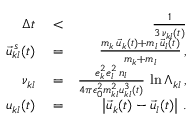Convert formula to latex. <formula><loc_0><loc_0><loc_500><loc_500>\begin{array} { r l r } { \Delta t } & < } & { \frac { 1 } { 3 \, \nu _ { k l } ( t ) } } \\ { \vec { u } _ { k l } ^ { \, s } ( t ) } & = } & { \frac { m _ { k } \, \vec { u } _ { k } ( t ) + m _ { l } \, \vec { u } _ { l } ( t ) } { m _ { k } + m _ { l } } \, , } \\ { \nu _ { k l } } & = } & { \frac { e _ { k } ^ { 2 } e _ { l } ^ { 2 } \, n _ { l } } { 4 \pi \epsilon _ { 0 } ^ { 2 } m _ { k l } ^ { 2 } u _ { k l } ^ { 3 } \left ( t \right ) } \, \ln \Lambda _ { k l } \, , } \\ { u _ { k l } ( t ) } & = } & { \left | \vec { u } _ { k } ( t ) - \vec { u } _ { l } ( t ) \right | \, . } \end{array}</formula> 